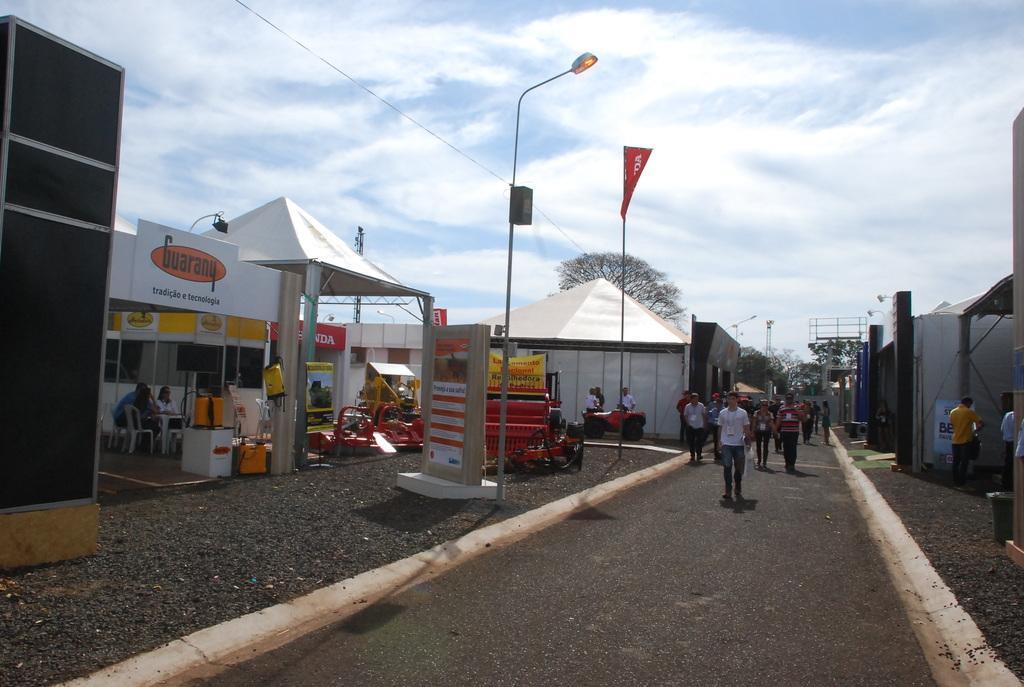In one or two sentences, can you explain what this image depicts? In the foreground of this picture, there is a path and persons walking on it. On the right side, there are person standing and buildings. In the background, there are poles, tents, boards, lights, a vehicle, name board, few persons standing, trees and the cloud. 